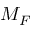<formula> <loc_0><loc_0><loc_500><loc_500>M _ { F }</formula> 